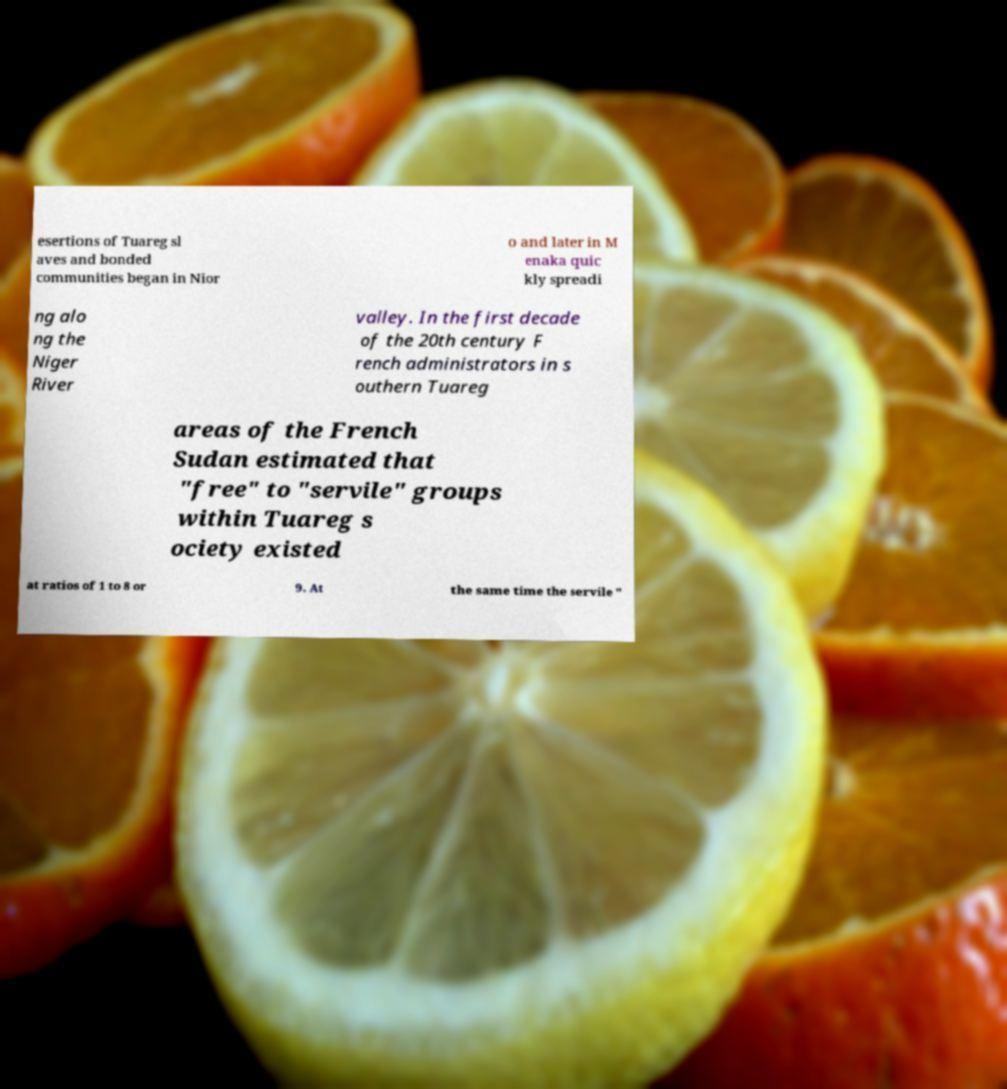Please read and relay the text visible in this image. What does it say? esertions of Tuareg sl aves and bonded communities began in Nior o and later in M enaka quic kly spreadi ng alo ng the Niger River valley. In the first decade of the 20th century F rench administrators in s outhern Tuareg areas of the French Sudan estimated that "free" to "servile" groups within Tuareg s ociety existed at ratios of 1 to 8 or 9. At the same time the servile " 